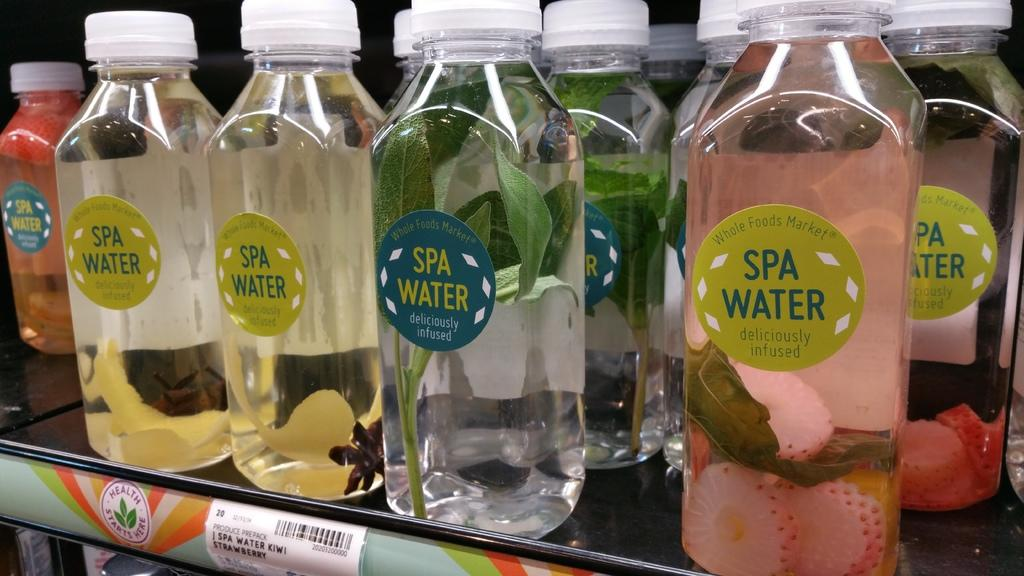What type of beverage containers are present in the image? There are juice bottles in the image. Can you see a goat in the image? No, there is no goat present in the image. What type of room is depicted in the image? The provided fact does not mention a room or any specific setting, so it cannot be determined from the image. 